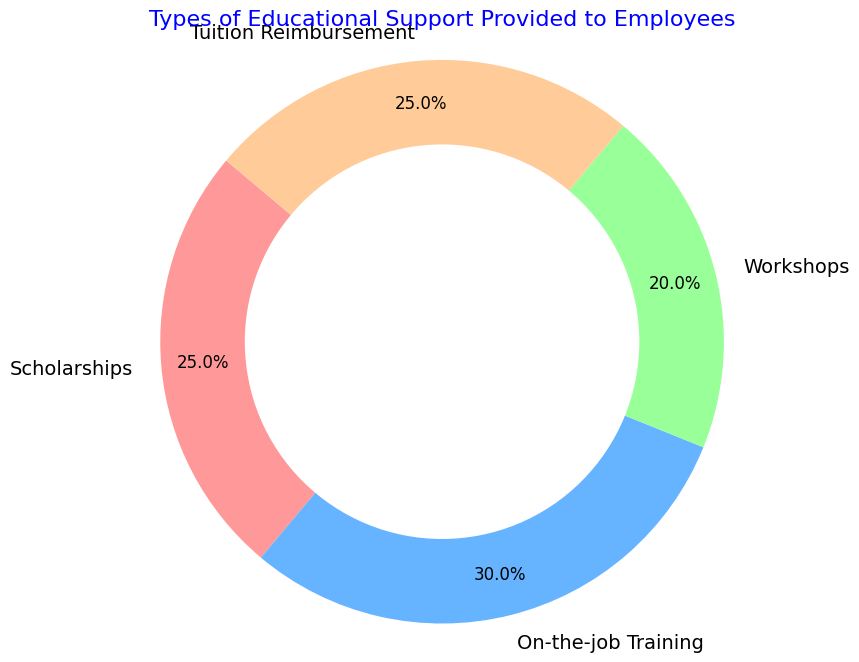Which type of support has the highest percentage? By looking at the pie chart, the support type with the largest slice represents the highest percentage. On-the-job Training has a slice covering 30%.
Answer: On-the-job Training Which two types of support have an equal percentage, and what is that percentage? From the pie chart, observe that Scholarships and Tuition Reimbursement have slices of equal size. Each of these covers 25%.
Answer: Scholarships and Tuition Reimbursement, 25% What is the combined percentage of Scholarships and Tuition Reimbursement? Sum the percentages of Scholarships (25%) and Tuition Reimbursement (25%). 25 + 25 = 50.
Answer: 50% What is the difference between the percentage of On-the-job Training and Workshops? Subtract the percentage of Workshops (20%) from On-the-job Training (30%). 30 - 20 = 10.
Answer: 10% If the total number of employees is 200, how many employees benefit from Workshops? 20% of the employees benefit from Workshops. Calculate 20% of 200 by multiplying 200 by 0.20. 200 * 0.20 = 40.
Answer: 40 How much smaller is the percentage of Workshops compared to On-the-job Training? Subtract the percentage of Workshops (20%) from On-the-job Training (30%). 30 - 20 = 10. Workshops are 10% smaller compared to On-the-job Training.
Answer: 10% What percentage of employees receive support types other than On-the-job Training? Subtract the percentage of On-the-job Training (30%) from 100%. 100 - 30 = 70.
Answer: 70% Rank the types of support from highest to lowest percentage. Determine the percentages and then order them: On-the-job Training (30%), Scholarships and Tuition Reimbursement (25% each), Workshops (20%).
Answer: On-the-job Training, Scholarships and Tuition Reimbursement, Workshops What is the average percentage of Scholarships and Workshops? Calculate the average by summing Scholarship (25%) and Workshops (20%) and then dividing by 2. (25 + 20)/2 = 45/2 = 22.5.
Answer: 22.5% What percentage of the chart do the smaller categories (below 30%) constitute? Sum the percentages of Scholarships (25%), Workshops (20%), and Tuition Reimbursement (25%). 25 + 20 + 25 = 70.
Answer: 70% 